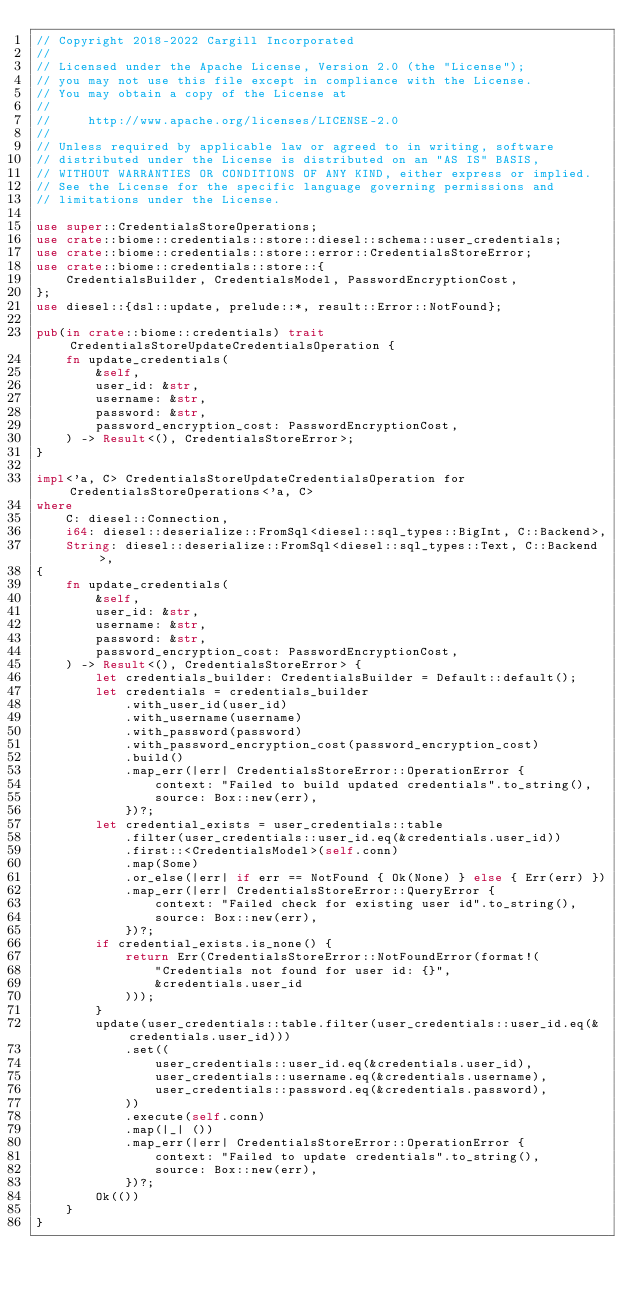<code> <loc_0><loc_0><loc_500><loc_500><_Rust_>// Copyright 2018-2022 Cargill Incorporated
//
// Licensed under the Apache License, Version 2.0 (the "License");
// you may not use this file except in compliance with the License.
// You may obtain a copy of the License at
//
//     http://www.apache.org/licenses/LICENSE-2.0
//
// Unless required by applicable law or agreed to in writing, software
// distributed under the License is distributed on an "AS IS" BASIS,
// WITHOUT WARRANTIES OR CONDITIONS OF ANY KIND, either express or implied.
// See the License for the specific language governing permissions and
// limitations under the License.

use super::CredentialsStoreOperations;
use crate::biome::credentials::store::diesel::schema::user_credentials;
use crate::biome::credentials::store::error::CredentialsStoreError;
use crate::biome::credentials::store::{
    CredentialsBuilder, CredentialsModel, PasswordEncryptionCost,
};
use diesel::{dsl::update, prelude::*, result::Error::NotFound};

pub(in crate::biome::credentials) trait CredentialsStoreUpdateCredentialsOperation {
    fn update_credentials(
        &self,
        user_id: &str,
        username: &str,
        password: &str,
        password_encryption_cost: PasswordEncryptionCost,
    ) -> Result<(), CredentialsStoreError>;
}

impl<'a, C> CredentialsStoreUpdateCredentialsOperation for CredentialsStoreOperations<'a, C>
where
    C: diesel::Connection,
    i64: diesel::deserialize::FromSql<diesel::sql_types::BigInt, C::Backend>,
    String: diesel::deserialize::FromSql<diesel::sql_types::Text, C::Backend>,
{
    fn update_credentials(
        &self,
        user_id: &str,
        username: &str,
        password: &str,
        password_encryption_cost: PasswordEncryptionCost,
    ) -> Result<(), CredentialsStoreError> {
        let credentials_builder: CredentialsBuilder = Default::default();
        let credentials = credentials_builder
            .with_user_id(user_id)
            .with_username(username)
            .with_password(password)
            .with_password_encryption_cost(password_encryption_cost)
            .build()
            .map_err(|err| CredentialsStoreError::OperationError {
                context: "Failed to build updated credentials".to_string(),
                source: Box::new(err),
            })?;
        let credential_exists = user_credentials::table
            .filter(user_credentials::user_id.eq(&credentials.user_id))
            .first::<CredentialsModel>(self.conn)
            .map(Some)
            .or_else(|err| if err == NotFound { Ok(None) } else { Err(err) })
            .map_err(|err| CredentialsStoreError::QueryError {
                context: "Failed check for existing user id".to_string(),
                source: Box::new(err),
            })?;
        if credential_exists.is_none() {
            return Err(CredentialsStoreError::NotFoundError(format!(
                "Credentials not found for user id: {}",
                &credentials.user_id
            )));
        }
        update(user_credentials::table.filter(user_credentials::user_id.eq(&credentials.user_id)))
            .set((
                user_credentials::user_id.eq(&credentials.user_id),
                user_credentials::username.eq(&credentials.username),
                user_credentials::password.eq(&credentials.password),
            ))
            .execute(self.conn)
            .map(|_| ())
            .map_err(|err| CredentialsStoreError::OperationError {
                context: "Failed to update credentials".to_string(),
                source: Box::new(err),
            })?;
        Ok(())
    }
}
</code> 